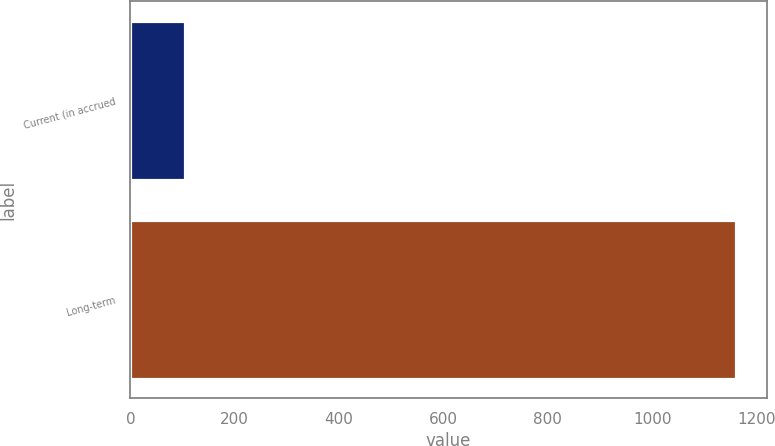Convert chart to OTSL. <chart><loc_0><loc_0><loc_500><loc_500><bar_chart><fcel>Current (in accrued<fcel>Long-term<nl><fcel>105<fcel>1161<nl></chart> 